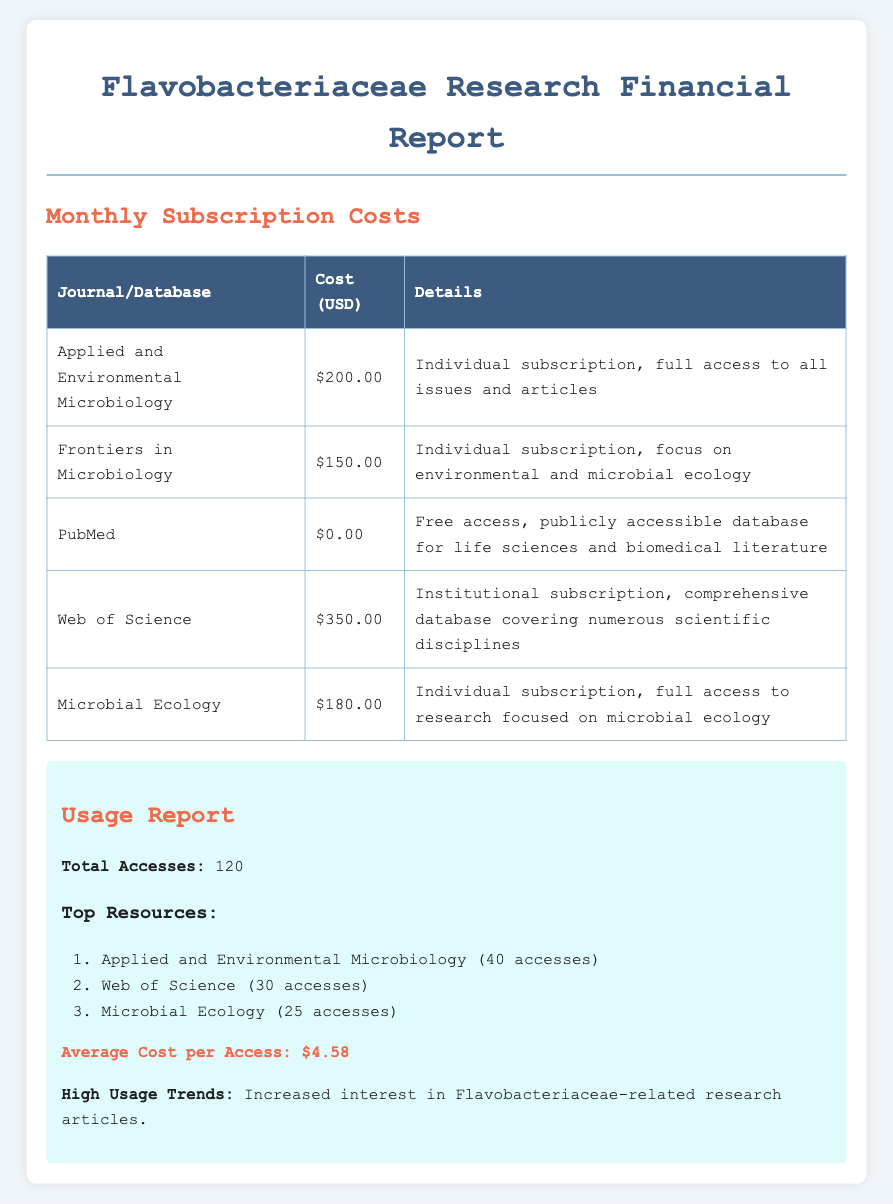What is the total cost of all subscriptions? The total cost is the sum of all the individual costs in the table: $200 + $150 + $0 + $350 + $180 = $880.
Answer: $880 Which journal has the highest subscription cost? The journal with the highest subscription cost is identified by comparing the costs listed in the document.
Answer: Web of Science What is the cost of an individual subscription to Microbial Ecology? This information is found in the itemized bills in the table.
Answer: $180.00 How many total accesses were recorded in the usage report? The total accesses are reported in the usage section of the document.
Answer: 120 What is the average cost per access? The average cost per access is calculated from the total cost divided by the total accesses: $880 / 120 = $4.58.
Answer: $4.58 Which subscription is free? This information is found within the itemized bills where it specifies subscriptions with no cost.
Answer: PubMed How many accesses did Applied and Environmental Microbiology receive? The number of accesses is noted next to each top resource in the usage report.
Answer: 40 accesses What are the high usage trends noted in the document? This information is found at the end of the usage report, highlighting research topics of interest.
Answer: Increased interest in Flavobacteriaceae-related research articles 